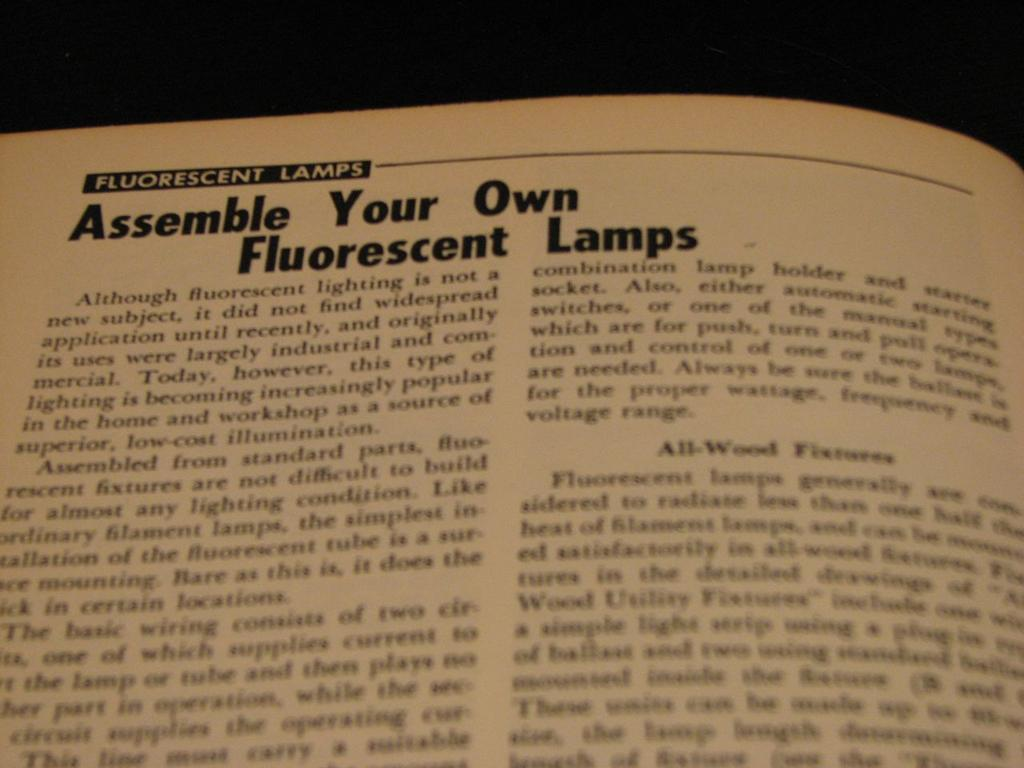<image>
Give a short and clear explanation of the subsequent image. an open page of a book that is titled 'fluorescent lamps' 